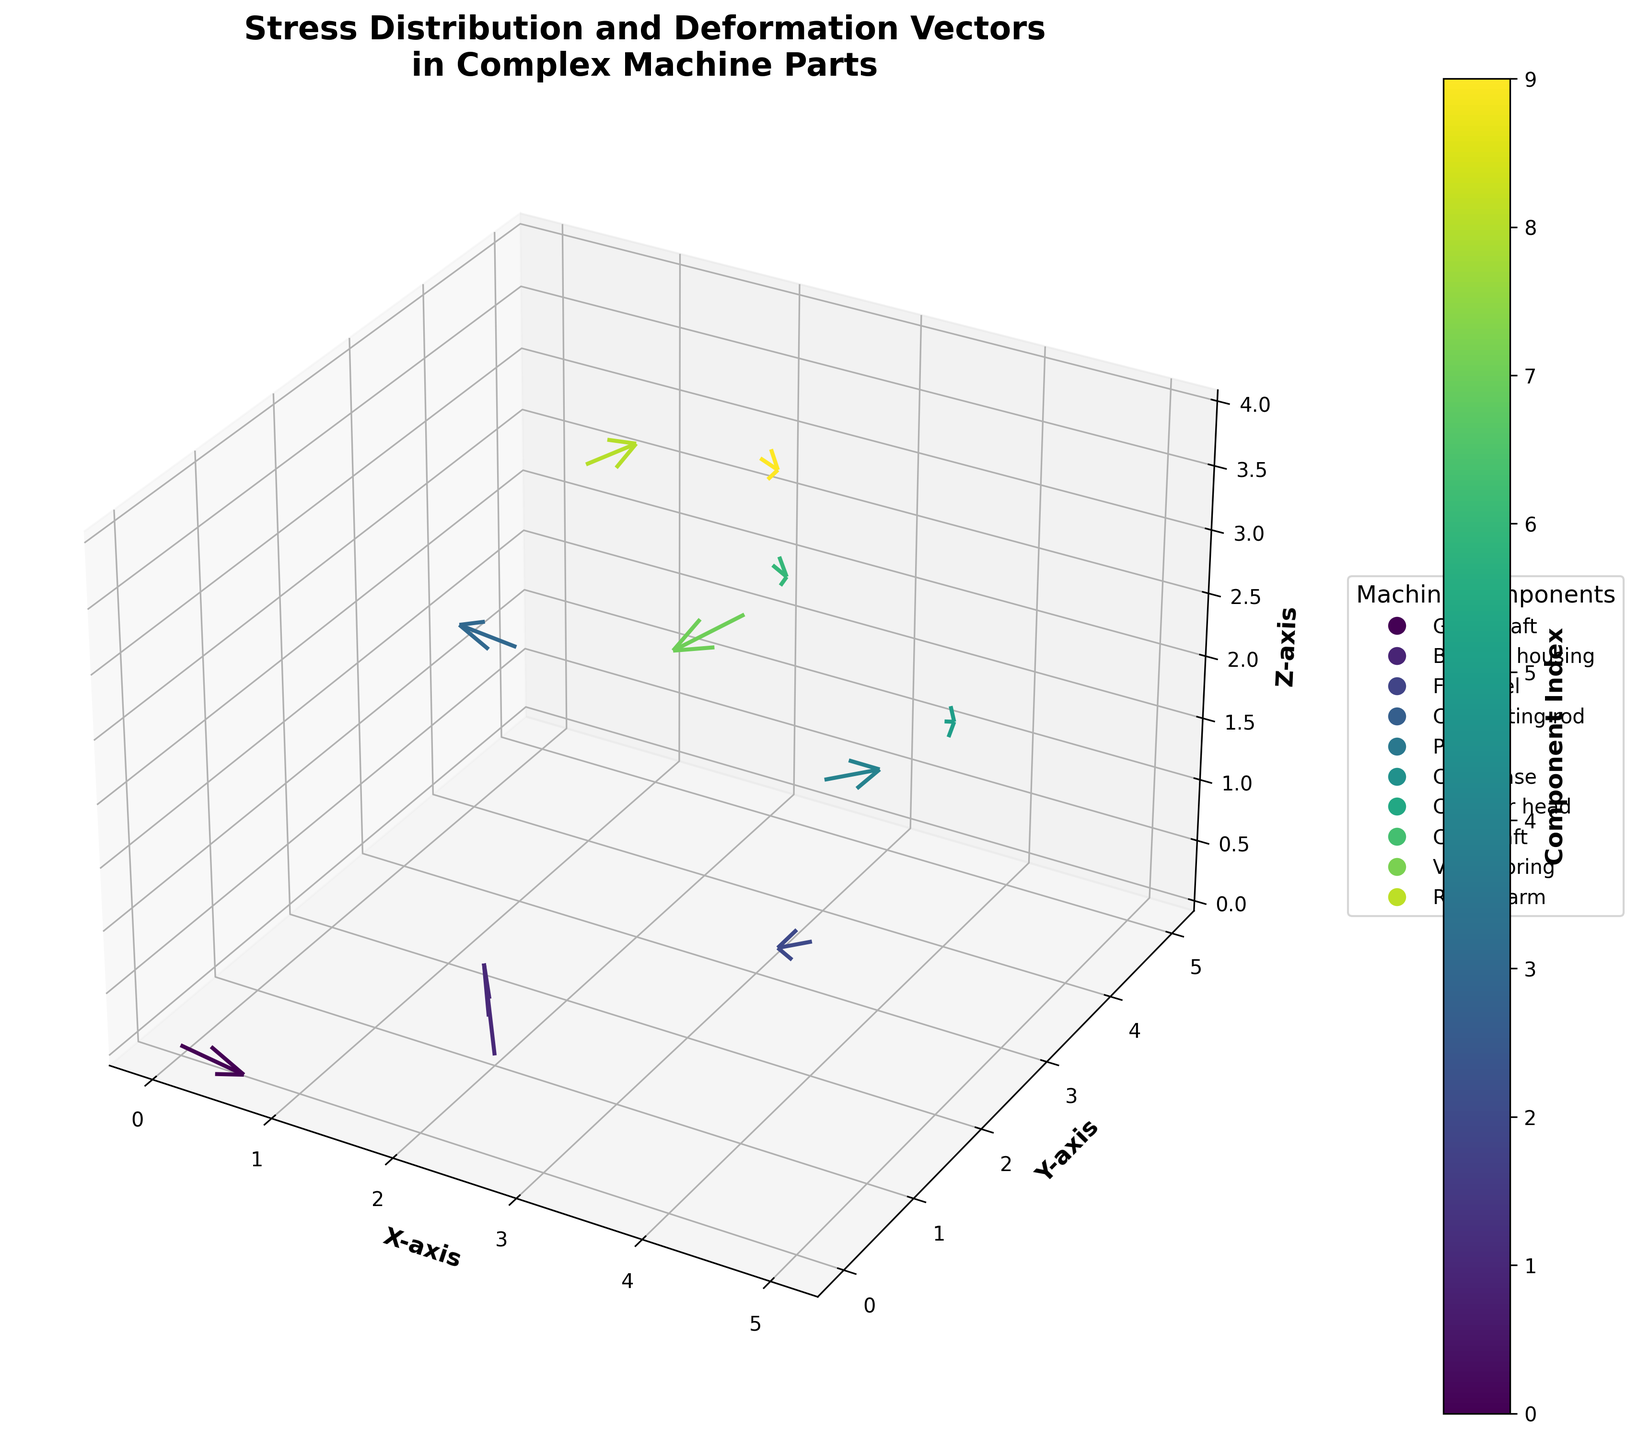What is the title of the plot? The title of the plot can be found at the top of the figure. It provides a summary of what the plot is about.
Answer: Stress Distribution and Deformation Vectors in Complex Machine Parts Which axis represents the vertical dimension? The axis labels indicate which dimension they represent. The vertical dimension is labeled as the "Y-axis".
Answer: Y-axis How many machine components are represented in the plot? Each data point with a vector corresponds to a different machine component, and there are 10 different vectors visible in the plot.
Answer: 10 Which component has the largest vector in terms of any single dimension? By comparing the magnitudes of the vectors in any dimension (x, y or z direction), the "Piston" component has a vector with a u-value of 0.6, which appears to be the largest single dimension vector component in the plot.
Answer: Piston Which vectors indicate a downward deformation in the Y direction? Downward deformation in the Y direction is indicated by a negative v-value for that vector. Components "Gear shaft", "Flywheel", "Piston", "Valve spring", and "Rocker arm" have such vectors.
Answer: Gear shaft, Flywheel, Piston, Valve spring, Rocker arm What is the color for the "Camshaft" component in the plot? Colors are assigned following the color map. The color for "Camshaft" can be identified by finding the corresponding marker in the legend.
Answer: Light green What is the average value of the Z-components (w) for all machine parts? Sum up all z-components (w) values: 0.1 + 0.2 + 0.3 - 0.1 + 0.4 - 0.3 + 0.2 - 0.4 + 0.3 - 0.2 = 0.5. Then, divide by the number of components (10).
Answer: 0.05 Which component is at the highest Z-axis position? The component with the highest Z value (among 'z') will be at the highest Z-axis position. "Camshaft" has a z-coordinate of 4, which is the highest value.
Answer: Camshaft 